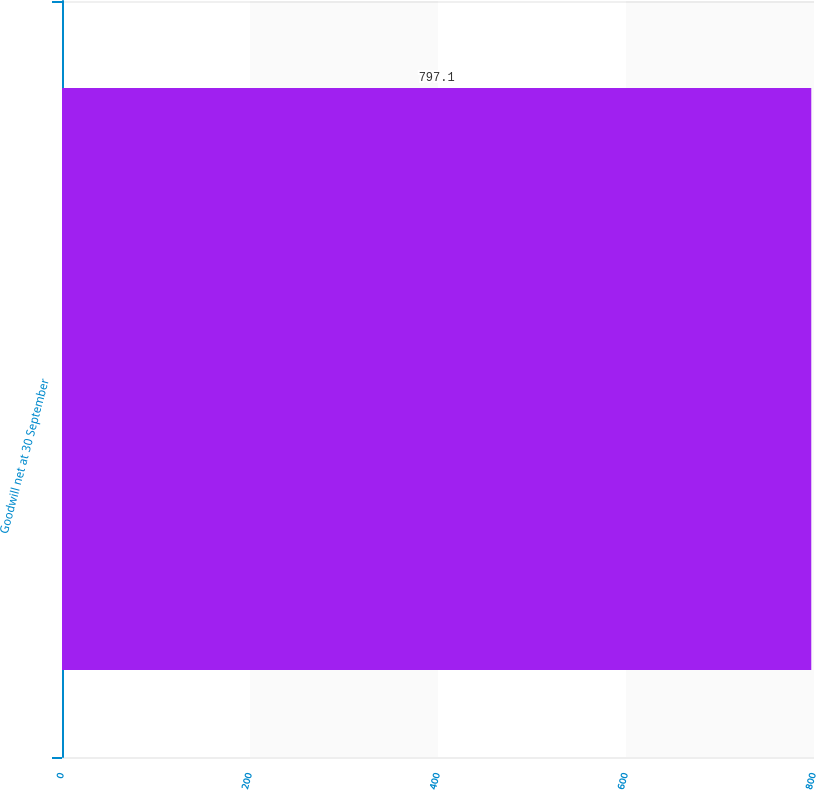<chart> <loc_0><loc_0><loc_500><loc_500><bar_chart><fcel>Goodwill net at 30 September<nl><fcel>797.1<nl></chart> 